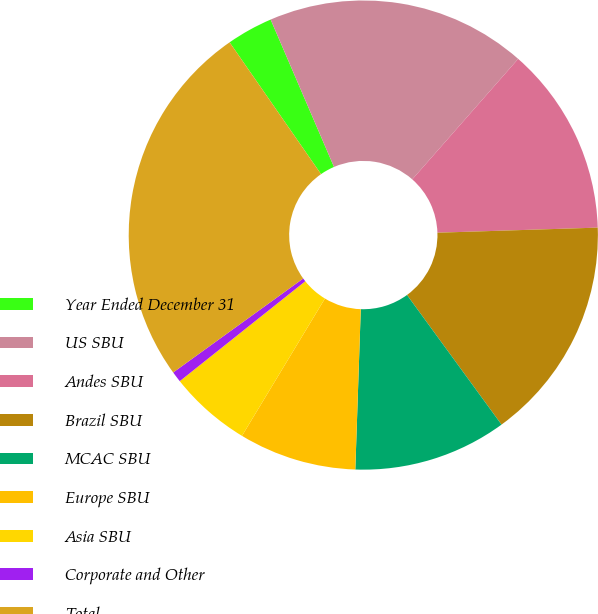Convert chart. <chart><loc_0><loc_0><loc_500><loc_500><pie_chart><fcel>Year Ended December 31<fcel>US SBU<fcel>Andes SBU<fcel>Brazil SBU<fcel>MCAC SBU<fcel>Europe SBU<fcel>Asia SBU<fcel>Corporate and Other<fcel>Total<nl><fcel>3.19%<fcel>17.94%<fcel>13.02%<fcel>15.48%<fcel>10.57%<fcel>8.11%<fcel>5.65%<fcel>0.74%<fcel>25.31%<nl></chart> 